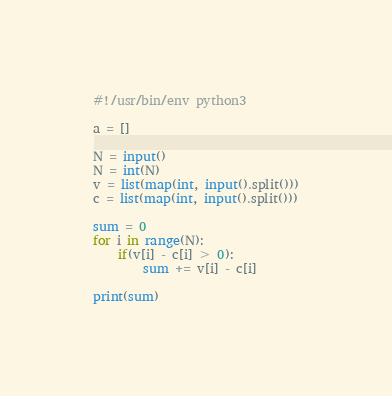<code> <loc_0><loc_0><loc_500><loc_500><_Python_>#!/usr/bin/env python3

a = []

N = input()
N = int(N)
v = list(map(int, input().split()))
c = list(map(int, input().split()))

sum = 0
for i in range(N):
    if(v[i] - c[i] > 0):
        sum += v[i] - c[i]

print(sum)
</code> 